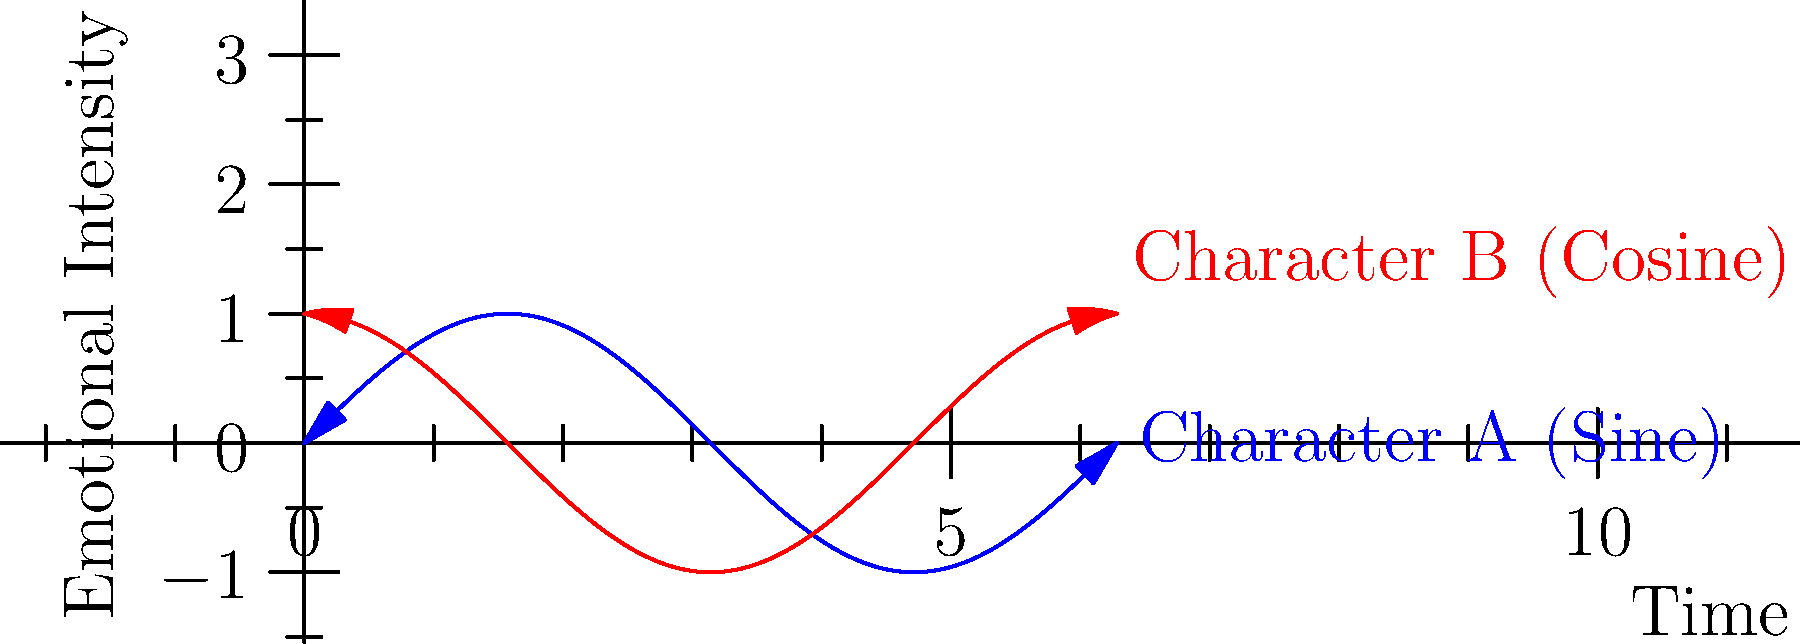In a screenplay featuring two characters from different cultural backgrounds, their emotional arcs are modeled using sine and cosine functions. Character A's emotional intensity is represented by $f(t) = \sin(t)$, while Character B's is represented by $g(t) = \cos(t)$, where $t$ is time in radians. At what point in the story (in terms of $\pi$) do both characters experience the same emotional intensity for the first time? To solve this problem, we need to find the first intersection point of the sine and cosine functions:

1) We need to solve the equation: $\sin(t) = \cos(t)$

2) This is equivalent to: $\sin(t) - \cos(t) = 0$

3) We can use the trigonometric identity: $\sin(t) - \cos(t) = \sqrt{2} \sin(t - \frac{\pi}{4})$

4) So, our equation becomes: $\sqrt{2} \sin(t - \frac{\pi}{4}) = 0$

5) The sine function equals zero when its argument is a multiple of $\pi$. So:

   $t - \frac{\pi}{4} = 0$

6) Solving for $t$:

   $t = \frac{\pi}{4}$

7) This is the first positive solution, which corresponds to the first intersection point in the first quadrant.

Therefore, the characters experience the same emotional intensity for the first time at $t = \frac{\pi}{4}$.
Answer: $\frac{\pi}{4}$ 